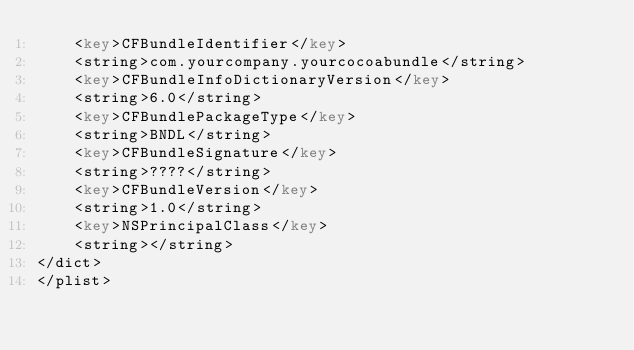Convert code to text. <code><loc_0><loc_0><loc_500><loc_500><_XML_>	<key>CFBundleIdentifier</key>
	<string>com.yourcompany.yourcocoabundle</string>
	<key>CFBundleInfoDictionaryVersion</key>
	<string>6.0</string>
	<key>CFBundlePackageType</key>
	<string>BNDL</string>
	<key>CFBundleSignature</key>
	<string>????</string>
	<key>CFBundleVersion</key>
	<string>1.0</string>
	<key>NSPrincipalClass</key>
	<string></string>
</dict>
</plist>
</code> 